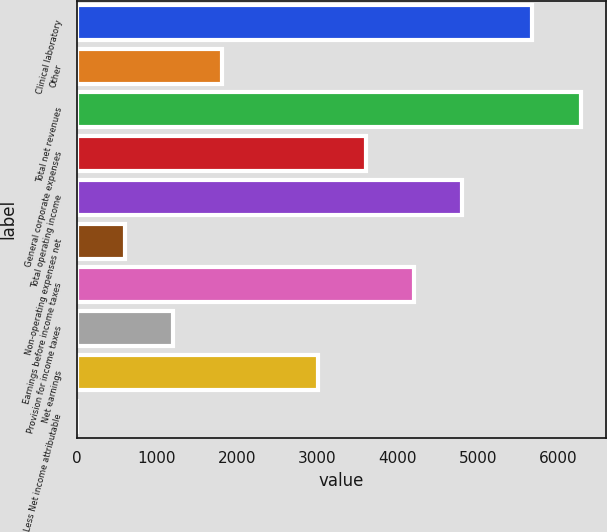Convert chart. <chart><loc_0><loc_0><loc_500><loc_500><bar_chart><fcel>Clinical laboratory<fcel>Other<fcel>Total net revenues<fcel>General corporate expenses<fcel>Total operating income<fcel>Non-operating expenses net<fcel>Earnings before income taxes<fcel>Provision for income taxes<fcel>Net earnings<fcel>Less Net income attributable<nl><fcel>5682.2<fcel>1804.46<fcel>6283.22<fcel>3607.52<fcel>4809.56<fcel>602.42<fcel>4208.54<fcel>1203.44<fcel>3006.5<fcel>1.4<nl></chart> 